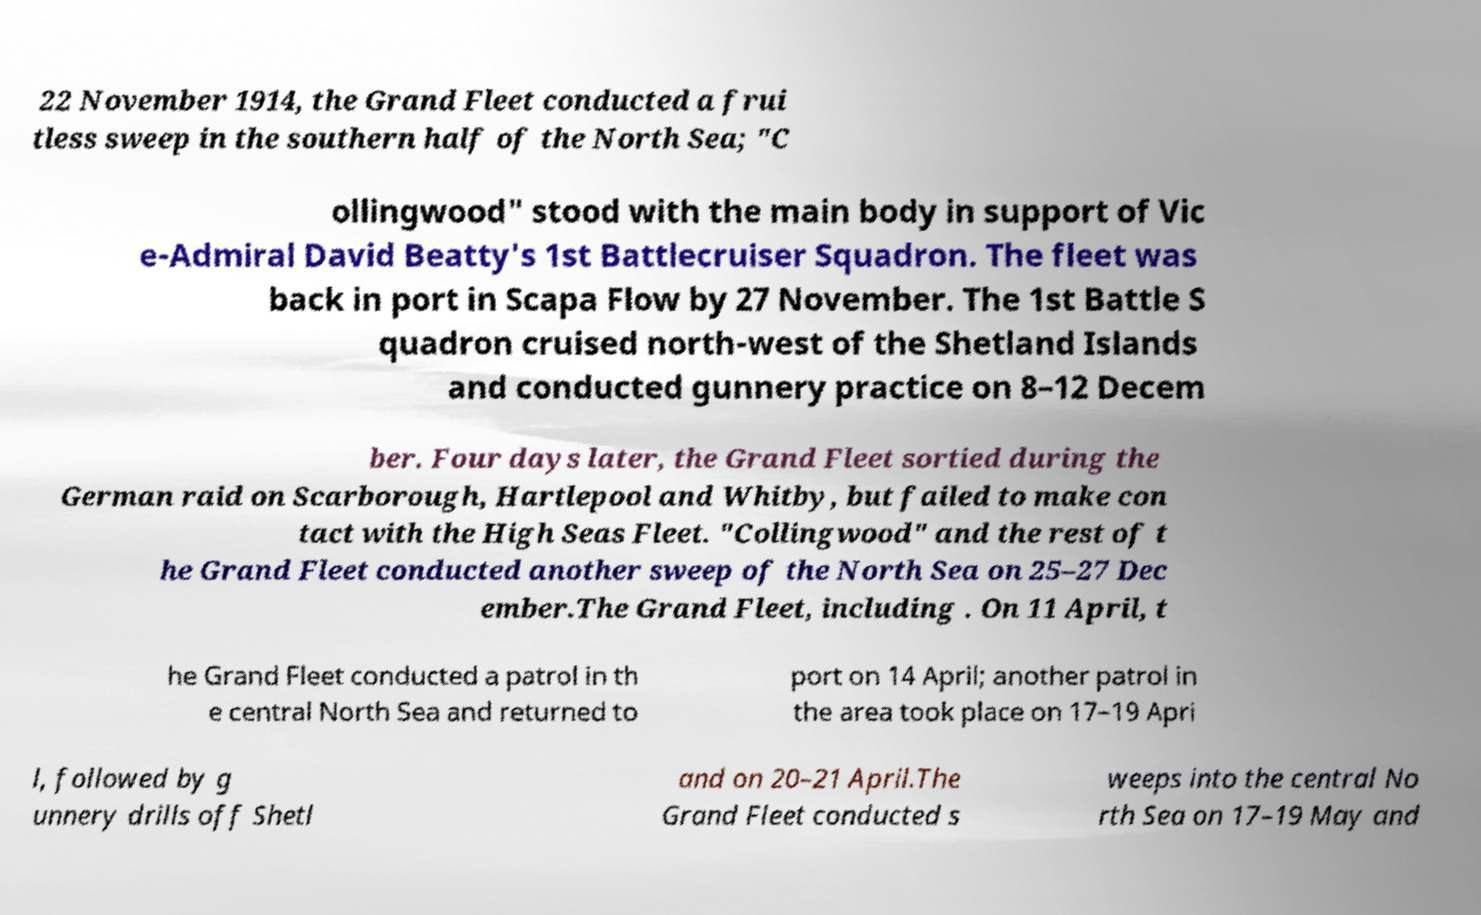Can you accurately transcribe the text from the provided image for me? 22 November 1914, the Grand Fleet conducted a frui tless sweep in the southern half of the North Sea; "C ollingwood" stood with the main body in support of Vic e-Admiral David Beatty's 1st Battlecruiser Squadron. The fleet was back in port in Scapa Flow by 27 November. The 1st Battle S quadron cruised north-west of the Shetland Islands and conducted gunnery practice on 8–12 Decem ber. Four days later, the Grand Fleet sortied during the German raid on Scarborough, Hartlepool and Whitby, but failed to make con tact with the High Seas Fleet. "Collingwood" and the rest of t he Grand Fleet conducted another sweep of the North Sea on 25–27 Dec ember.The Grand Fleet, including . On 11 April, t he Grand Fleet conducted a patrol in th e central North Sea and returned to port on 14 April; another patrol in the area took place on 17–19 Apri l, followed by g unnery drills off Shetl and on 20–21 April.The Grand Fleet conducted s weeps into the central No rth Sea on 17–19 May and 